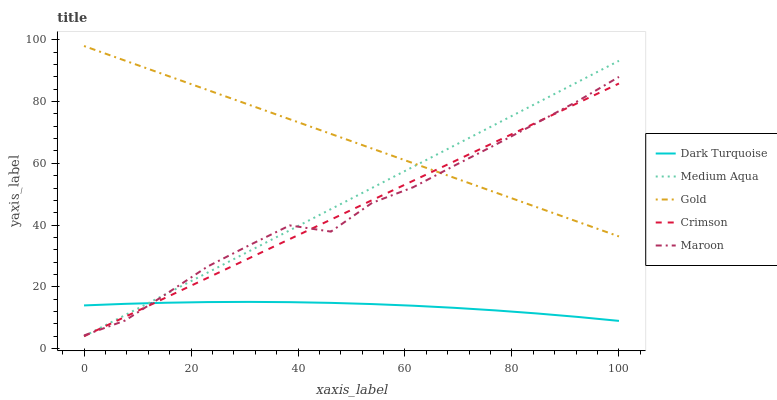Does Medium Aqua have the minimum area under the curve?
Answer yes or no. No. Does Medium Aqua have the maximum area under the curve?
Answer yes or no. No. Is Dark Turquoise the smoothest?
Answer yes or no. No. Is Dark Turquoise the roughest?
Answer yes or no. No. Does Dark Turquoise have the lowest value?
Answer yes or no. No. Does Medium Aqua have the highest value?
Answer yes or no. No. Is Dark Turquoise less than Gold?
Answer yes or no. Yes. Is Gold greater than Dark Turquoise?
Answer yes or no. Yes. Does Dark Turquoise intersect Gold?
Answer yes or no. No. 